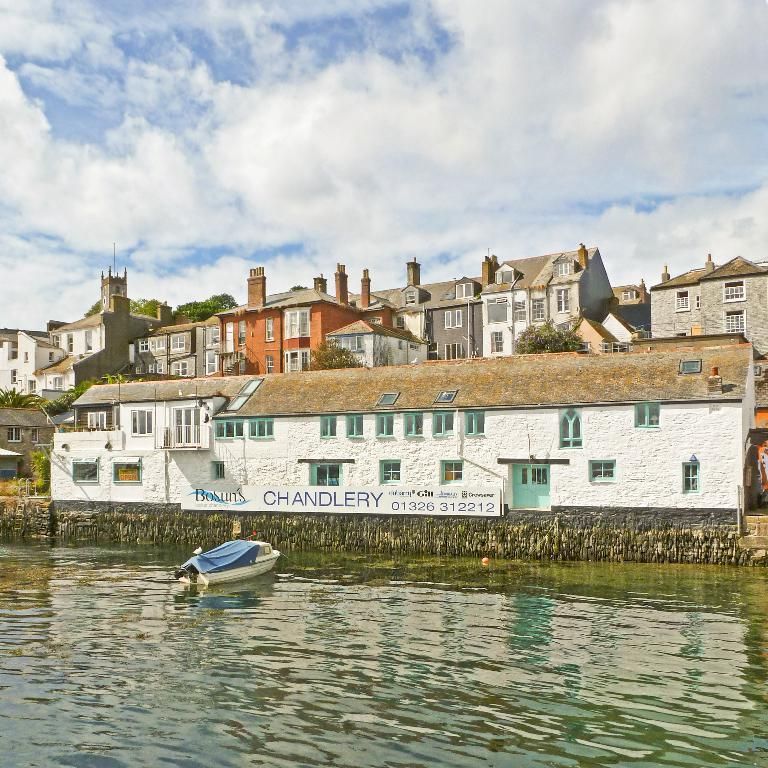What type of vehicle is in the image? There is a motor boat in the image. Where is the motor boat located? The motor boat is on a river. What can be seen on the other side of the river? There are buildings and trees on the other side of the river. What type of sofa is floating in the river in the image? There is no sofa present in the image; it features a motor boat on a river. What type of coat is being worn by the thing in the image? There is no "thing" or coat present in the image. 